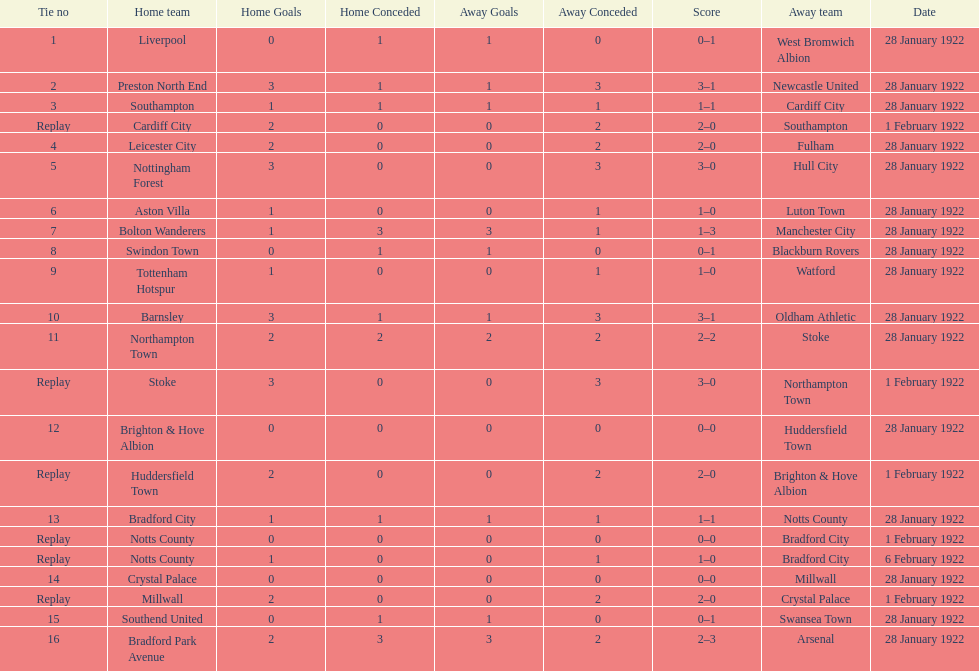What home team had the same score as aston villa on january 28th, 1922? Tottenham Hotspur. 